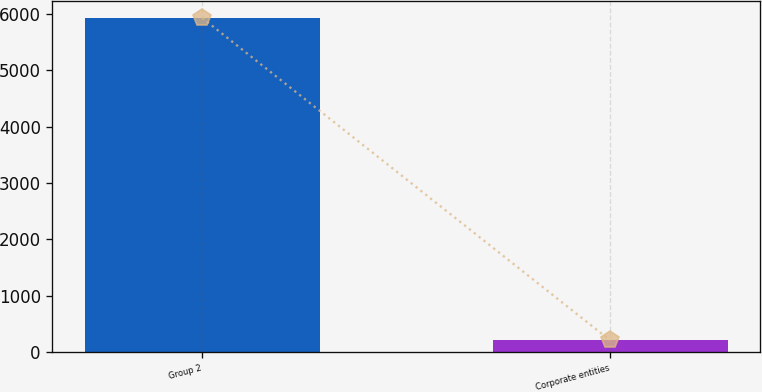<chart> <loc_0><loc_0><loc_500><loc_500><bar_chart><fcel>Group 2<fcel>Corporate entities<nl><fcel>5930<fcel>202.5<nl></chart> 